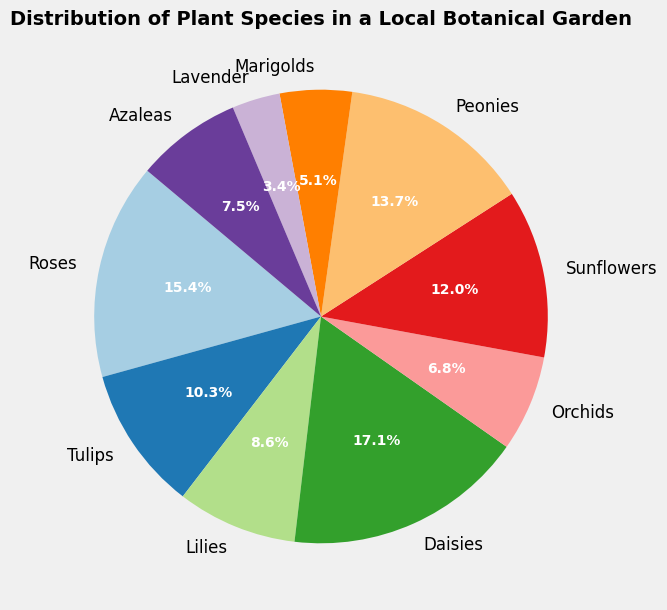Which plant species is the most common in the botanical garden? Look at the pie chart and identify the segment with the largest size. The label and percentage will indicate the most common species.
Answer: Daisies Which plant species has the smallest representation in the botanical garden? Observe the pie chart and find the smallest segment. The label and percentage provide the answer.
Answer: Lavender How many plant species have a count greater than 30? Check the pie chart and count the segments where the percentages correspond to a count greater than 30.
Answer: 5 What is the combined percentage of Roses and Tulips in the botanical garden? Find the segments for Roses and Tulips, then add their percentages together.
Answer: 31.9% Which plant species are more common: Sunflowers or Lilies? Compare the size of the segments for Sunflowers and Lilies by looking at their percentages.
Answer: Sunflowers Is the count of Peonies more or less than that of Azaleas? Compare the sizes of the segments or the percentages for Peonies and Azaleas.
Answer: More What is the difference in the count between Daisies and Marigolds? Look at the counts for Daisies and Marigolds, then subtract the smaller count from the larger one. 50 - 15 = 35
Answer: 35 What fraction of the total is represented by Orchids and Azaleas combined? Sum the counts for Orchids and Azaleas and divide by the total count. (20 + 22) / (45 + 30 + 25 + 50 + 20 + 35 + 40 + 15 + 10 + 22) = 42 / 292 ≈ 14.4%
Answer: 14.4% How does the count of Tulips compare to the combined count of Marigolds and Lavender? Sum the counts of Marigolds and Lavender and compare it to the count of Tulips. 15 + 10 = 25, and compare it with 30.
Answer: Tulips are more What are the primary colors used to represent Roses and Sunflowers in the chart? Glance at the color-coding in the pie chart and identify the primary colors assigned to the segments for Roses and Sunflowers.
Answer: Various distinct colors from colormap 